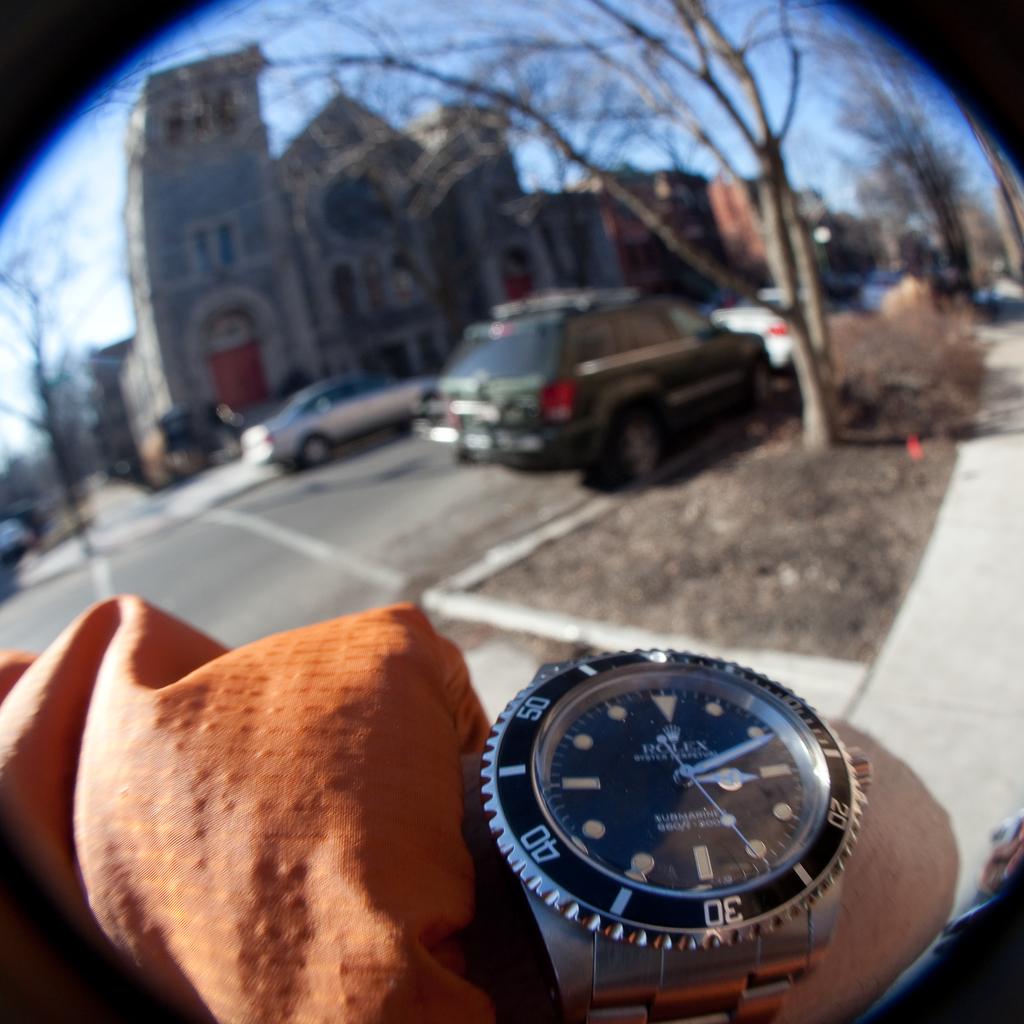What time is it?
Your answer should be very brief. 3:11. Is this a genuine rolex?
Provide a succinct answer. Yes. 